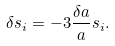Convert formula to latex. <formula><loc_0><loc_0><loc_500><loc_500>\delta s _ { i } = - 3 \frac { \delta a } { a } s _ { i } .</formula> 